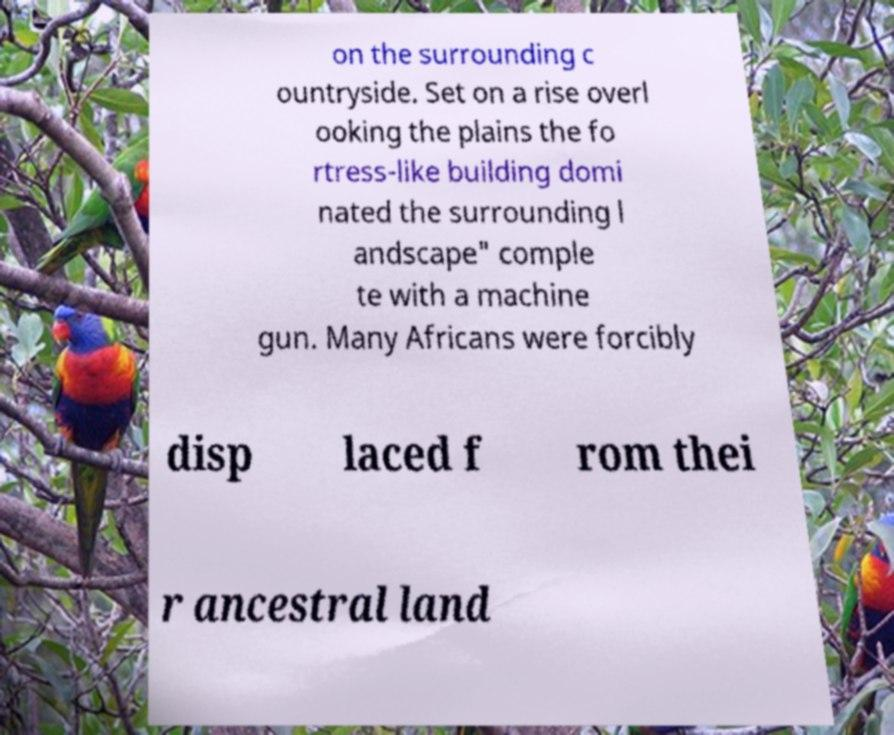There's text embedded in this image that I need extracted. Can you transcribe it verbatim? on the surrounding c ountryside. Set on a rise overl ooking the plains the fo rtress-like building domi nated the surrounding l andscape" comple te with a machine gun. Many Africans were forcibly disp laced f rom thei r ancestral land 